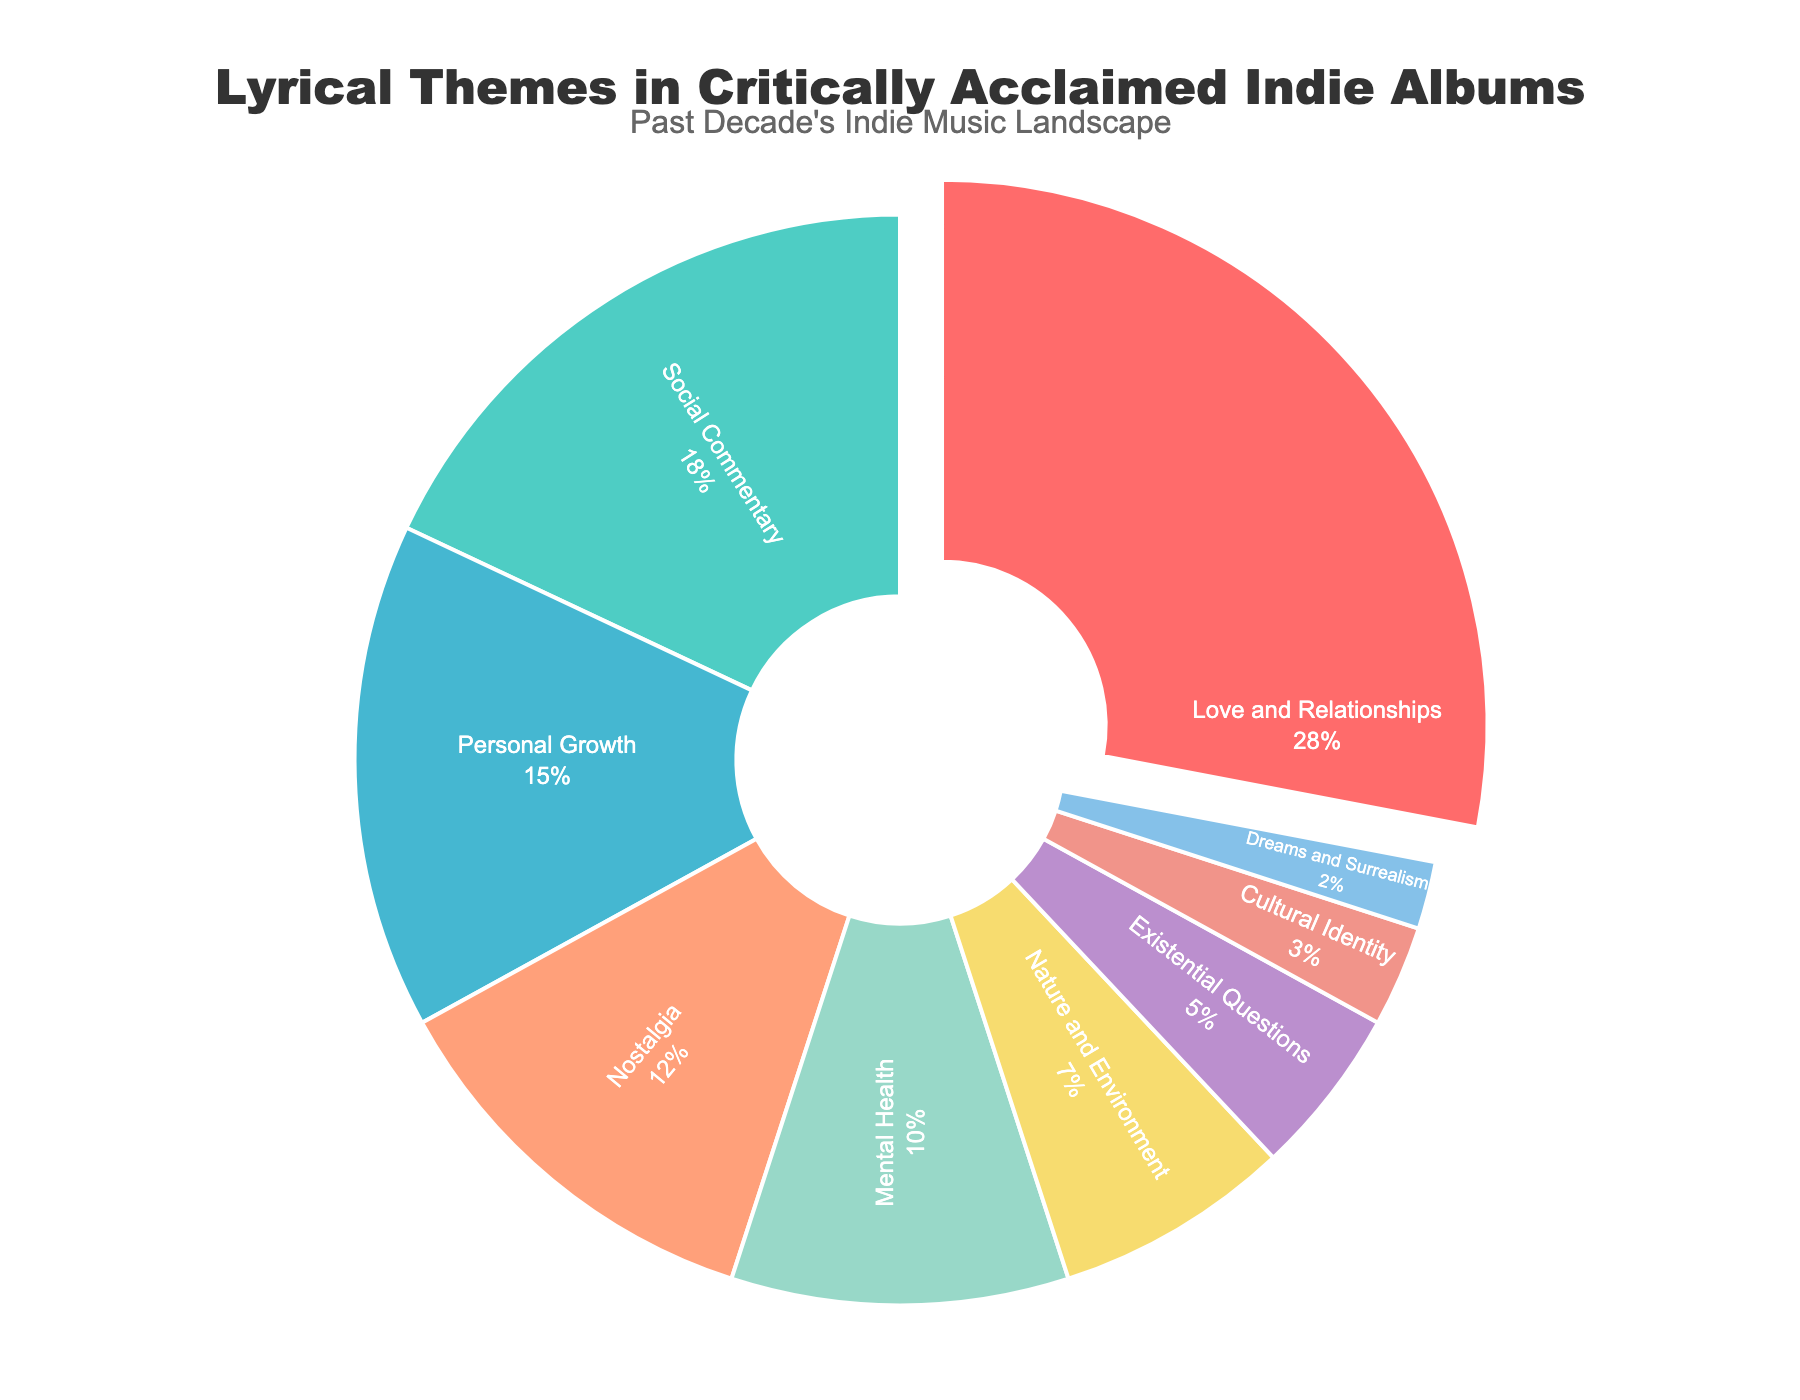Which lyrical theme is the most dominant in critically acclaimed indie albums? The most dominant theme will pull slightly away from the pie chart. "Love and Relationships" is pulled out and occupies the largest slice.
Answer: Love and Relationships How many lyrical themes constitute 10% or more of the total themes? We identify slices greater than or equal to 10% by looking at the position and size. The slices labeled "Love and Relationships," "Social Commentary," "Personal Growth," "Nostalgia," and "Mental Health" are 28%, 18%, 15%, 12%, and 10%, respectively.
Answer: 5 Which theme has a similar percentage to Personal Growth? Compare the percentages. "Nostalgia" (12%) is close to "Personal Growth" (15%).
Answer: Nostalgia What is the combined percentage of the smallest three lyrical themes? Sum the percentages of the three smallest slices. "Dreams and Surrealism" (2%), "Cultural Identity" (3%), "Existential Questions" (5%) gives 2 + 3 + 5.
Answer: 10% Is Mental Health more or less prevalent than Nature and Environment in indie albums? Compare their percentages visually. "Mental Health" is 10%, and "Nature and Environment" is 7%.
Answer: More Which lyrical theme is represented by the turquoise color in the chart? Identify the slice colored turquoise, which is associated with the percentage label. "Social Commentary" in turquoise shows an 18% share.
Answer: Social Commentary Are love and relationships depicted more or less than the combined themes of Mental Health and Personal Growth? Sum the percentages for "Mental Health" (10%) and "Personal Growth" (15%), which equals 25%. Compare with "Love and Relationships" (28%).
Answer: More 